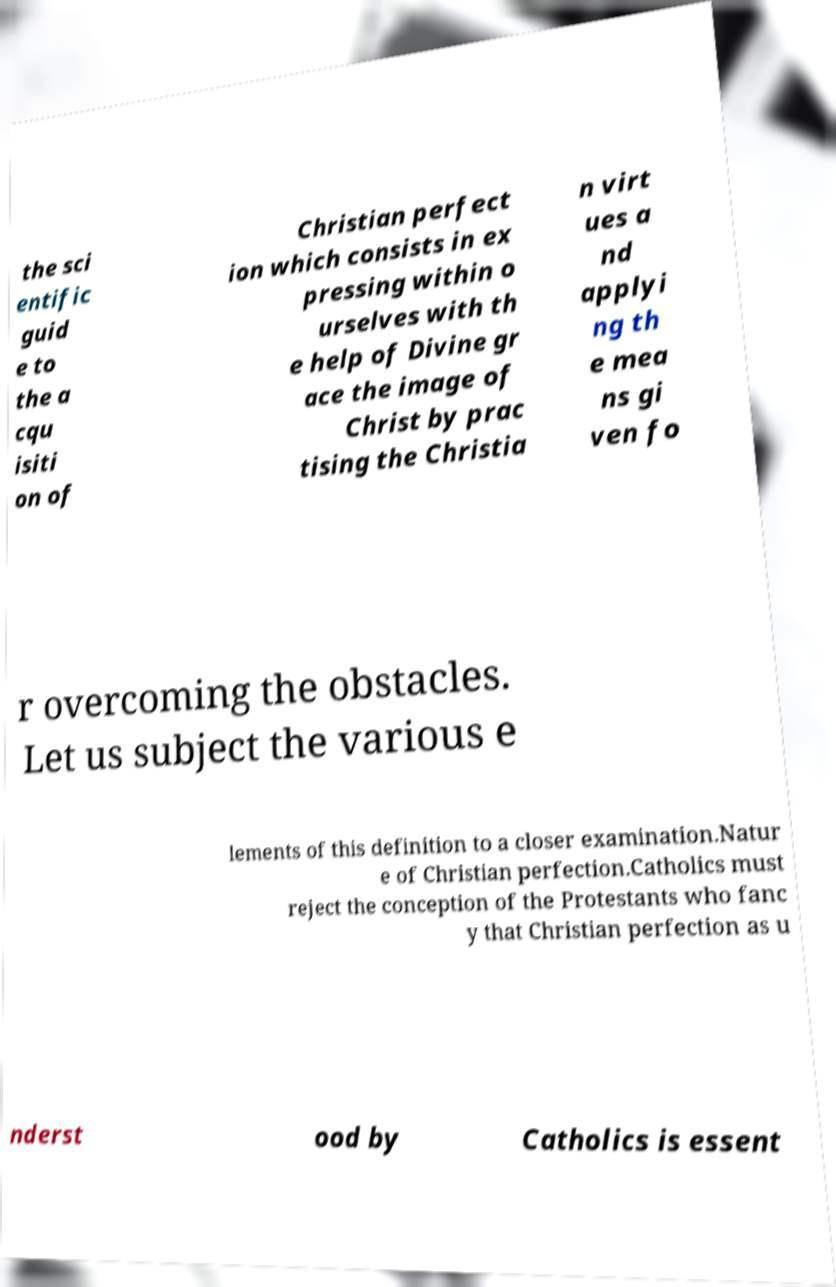What messages or text are displayed in this image? I need them in a readable, typed format. the sci entific guid e to the a cqu isiti on of Christian perfect ion which consists in ex pressing within o urselves with th e help of Divine gr ace the image of Christ by prac tising the Christia n virt ues a nd applyi ng th e mea ns gi ven fo r overcoming the obstacles. Let us subject the various e lements of this definition to a closer examination.Natur e of Christian perfection.Catholics must reject the conception of the Protestants who fanc y that Christian perfection as u nderst ood by Catholics is essent 